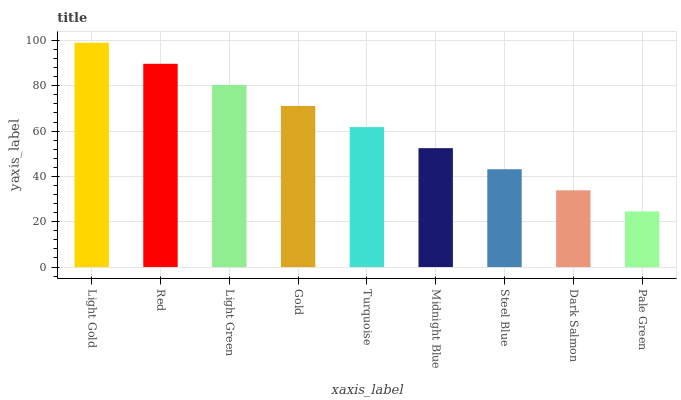Is Pale Green the minimum?
Answer yes or no. Yes. Is Light Gold the maximum?
Answer yes or no. Yes. Is Red the minimum?
Answer yes or no. No. Is Red the maximum?
Answer yes or no. No. Is Light Gold greater than Red?
Answer yes or no. Yes. Is Red less than Light Gold?
Answer yes or no. Yes. Is Red greater than Light Gold?
Answer yes or no. No. Is Light Gold less than Red?
Answer yes or no. No. Is Turquoise the high median?
Answer yes or no. Yes. Is Turquoise the low median?
Answer yes or no. Yes. Is Pale Green the high median?
Answer yes or no. No. Is Gold the low median?
Answer yes or no. No. 